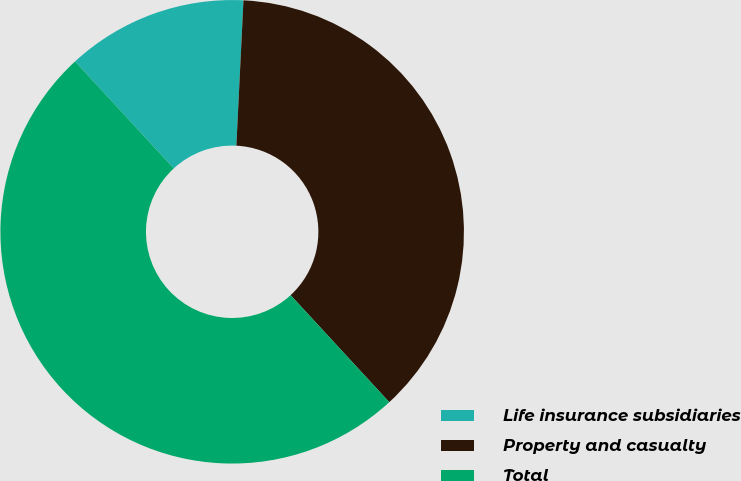Convert chart. <chart><loc_0><loc_0><loc_500><loc_500><pie_chart><fcel>Life insurance subsidiaries<fcel>Property and casualty<fcel>Total<nl><fcel>12.63%<fcel>37.37%<fcel>50.0%<nl></chart> 